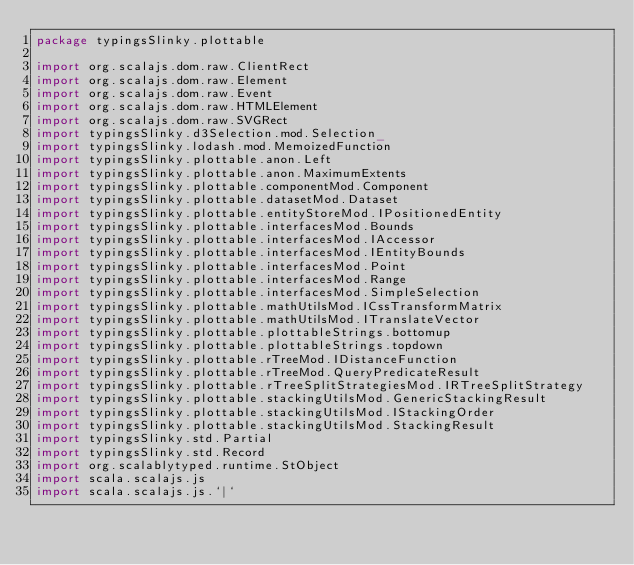Convert code to text. <code><loc_0><loc_0><loc_500><loc_500><_Scala_>package typingsSlinky.plottable

import org.scalajs.dom.raw.ClientRect
import org.scalajs.dom.raw.Element
import org.scalajs.dom.raw.Event
import org.scalajs.dom.raw.HTMLElement
import org.scalajs.dom.raw.SVGRect
import typingsSlinky.d3Selection.mod.Selection_
import typingsSlinky.lodash.mod.MemoizedFunction
import typingsSlinky.plottable.anon.Left
import typingsSlinky.plottable.anon.MaximumExtents
import typingsSlinky.plottable.componentMod.Component
import typingsSlinky.plottable.datasetMod.Dataset
import typingsSlinky.plottable.entityStoreMod.IPositionedEntity
import typingsSlinky.plottable.interfacesMod.Bounds
import typingsSlinky.plottable.interfacesMod.IAccessor
import typingsSlinky.plottable.interfacesMod.IEntityBounds
import typingsSlinky.plottable.interfacesMod.Point
import typingsSlinky.plottable.interfacesMod.Range
import typingsSlinky.plottable.interfacesMod.SimpleSelection
import typingsSlinky.plottable.mathUtilsMod.ICssTransformMatrix
import typingsSlinky.plottable.mathUtilsMod.ITranslateVector
import typingsSlinky.plottable.plottableStrings.bottomup
import typingsSlinky.plottable.plottableStrings.topdown
import typingsSlinky.plottable.rTreeMod.IDistanceFunction
import typingsSlinky.plottable.rTreeMod.QueryPredicateResult
import typingsSlinky.plottable.rTreeSplitStrategiesMod.IRTreeSplitStrategy
import typingsSlinky.plottable.stackingUtilsMod.GenericStackingResult
import typingsSlinky.plottable.stackingUtilsMod.IStackingOrder
import typingsSlinky.plottable.stackingUtilsMod.StackingResult
import typingsSlinky.std.Partial
import typingsSlinky.std.Record
import org.scalablytyped.runtime.StObject
import scala.scalajs.js
import scala.scalajs.js.`|`</code> 